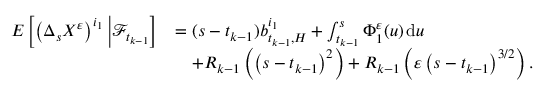Convert formula to latex. <formula><loc_0><loc_0><loc_500><loc_500>\begin{array} { r l } { E \left [ \left ( \Delta _ { s } X ^ { \varepsilon } \right ) ^ { i _ { 1 } } \Big | \mathcal { F } _ { t _ { k - 1 } } \right ] } & { = ( s - t _ { k - 1 } ) b _ { t _ { k - 1 } , H } ^ { i _ { 1 } } + \int _ { t _ { k - 1 } } ^ { s } \Phi _ { 1 } ^ { \varepsilon } ( u ) \, d u } \\ & { \quad + R _ { k - 1 } \left ( \left ( s - t _ { k - 1 } \right ) ^ { 2 } \right ) + R _ { k - 1 } \left ( \varepsilon \left ( s - t _ { k - 1 } \right ) ^ { 3 / 2 } \right ) . } \end{array}</formula> 